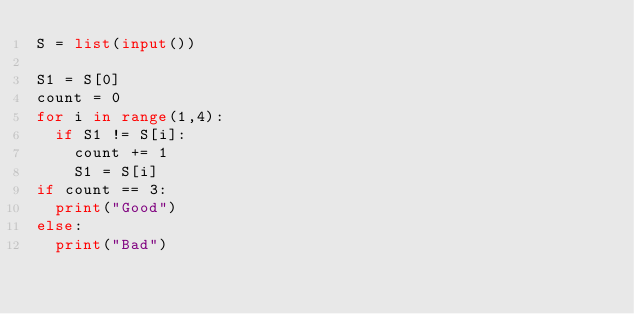<code> <loc_0><loc_0><loc_500><loc_500><_Python_>S = list(input())

S1 = S[0]
count = 0
for i in range(1,4):
  if S1 != S[i]:
    count += 1
    S1 = S[i]
if count == 3:
  print("Good")
else:
  print("Bad")</code> 